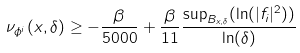<formula> <loc_0><loc_0><loc_500><loc_500>\nu _ { \phi ^ { i } } ( x , \delta ) \geq - \frac { \beta } { 5 0 0 0 } + \frac { \beta } { 1 1 } \frac { \sup _ { B _ { x , \delta } } ( \ln ( | f _ { i } | ^ { 2 } ) ) } { \ln ( \delta ) }</formula> 